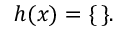<formula> <loc_0><loc_0><loc_500><loc_500>h ( x ) = \{ \, \} .</formula> 